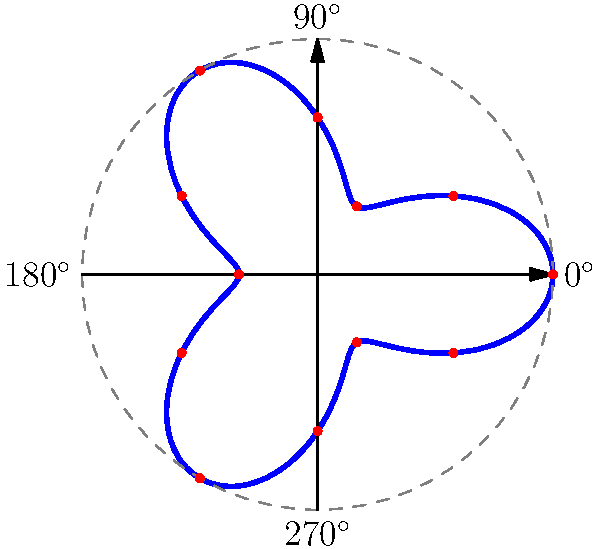As the head coach, you're analyzing the goalkeeper's diving reach. The polar equation $r = 2 + \cos(3\theta)$ represents the maximum distance (in meters) the goalkeeper can dive in different directions. What is the goalkeeper's maximum diving reach, and in which direction(s) does it occur? To find the maximum diving reach and its direction(s), we need to follow these steps:

1) The polar equation is given as $r = 2 + \cos(3\theta)$.

2) The maximum value of $\cos(3\theta)$ is 1, which occurs when $3\theta = 0°, 360°, 720°$, etc.

3) Solving for $\theta$:
   $\theta = 0°, 120°, 240°$

4) When $\cos(3\theta) = 1$, the maximum value of $r$ is:
   $r_{max} = 2 + 1 = 3$ meters

5) To convert these angles to compass directions:
   $0°$ corresponds to directly to the right (East)
   $120°$ corresponds to the upper left (Northwest)
   $240°$ corresponds to the lower left (Southwest)

Therefore, the goalkeeper's maximum diving reach is 3 meters, occurring in three directions: directly to the right, upper left, and lower left.
Answer: 3 meters; right (0°), upper left (120°), and lower left (240°) 